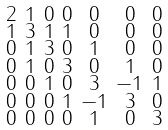Convert formula to latex. <formula><loc_0><loc_0><loc_500><loc_500>\begin{smallmatrix} 2 & 1 & 0 & 0 & 0 & 0 & 0 \\ 1 & 3 & 1 & 1 & 0 & 0 & 0 \\ 0 & 1 & 3 & 0 & 1 & 0 & 0 \\ 0 & 1 & 0 & 3 & 0 & 1 & 0 \\ 0 & 0 & 1 & 0 & 3 & - 1 & 1 \\ 0 & 0 & 0 & 1 & - 1 & 3 & 0 \\ 0 & 0 & 0 & 0 & 1 & 0 & 3 \end{smallmatrix}</formula> 